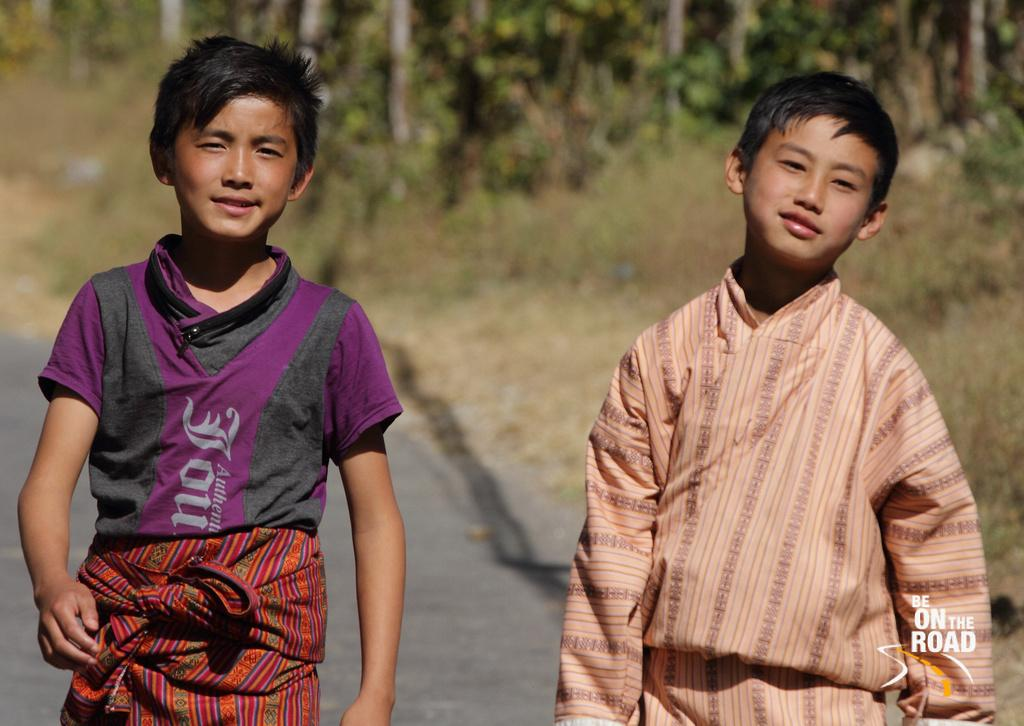How many people are in the image? There are two boys standing in the image. What are the boys doing in the image? The boys are smiling. What can be seen in the background of the image? There are trees in the background of the image. Is there any additional information about the image itself? Yes, there is a watermark on the image. What is the price of the hand in the image? There is no hand present in the image, and therefore no price can be determined. 